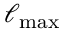Convert formula to latex. <formula><loc_0><loc_0><loc_500><loc_500>\ell _ { \max }</formula> 